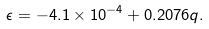Convert formula to latex. <formula><loc_0><loc_0><loc_500><loc_500>\epsilon = - 4 . 1 \times 1 0 ^ { - 4 } + 0 . 2 0 7 6 q .</formula> 